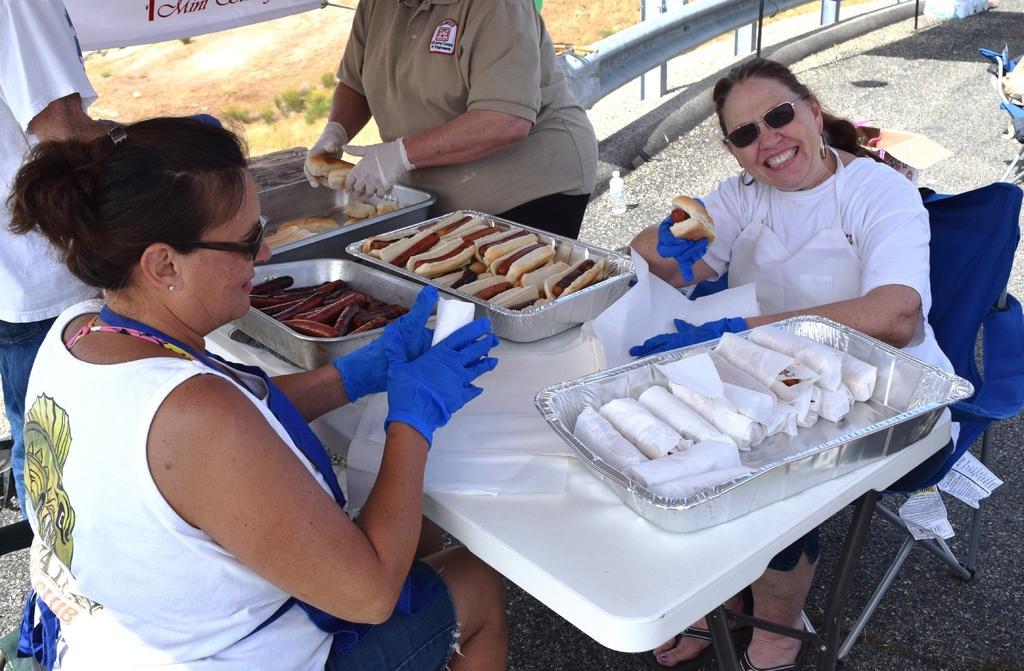Describe this image in one or two sentences. In this image there is a table and we can see hotdogs and napkins placed on the table and there are people sitting. Two of them are standing. In the background there is a road and a board. 